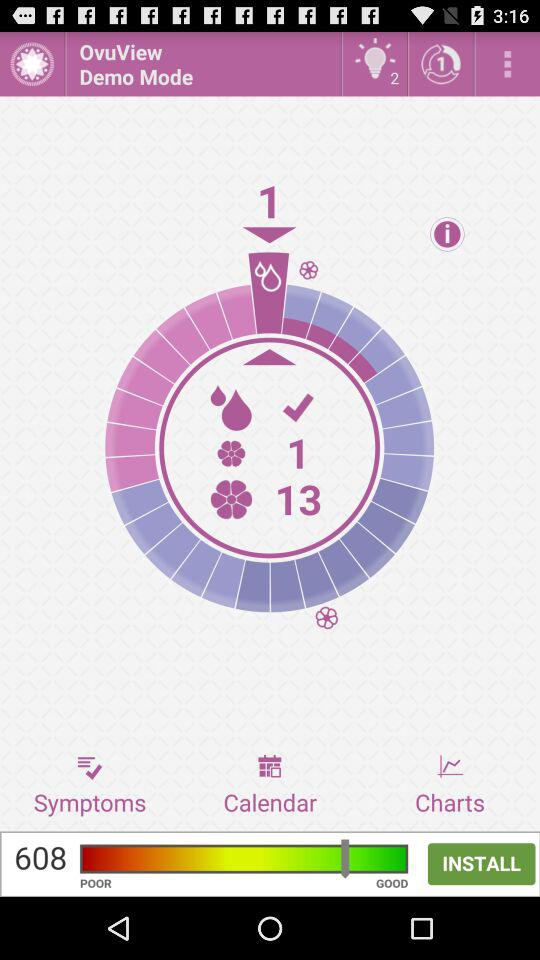How many notifications are unread? There are 2 unread notifications. 